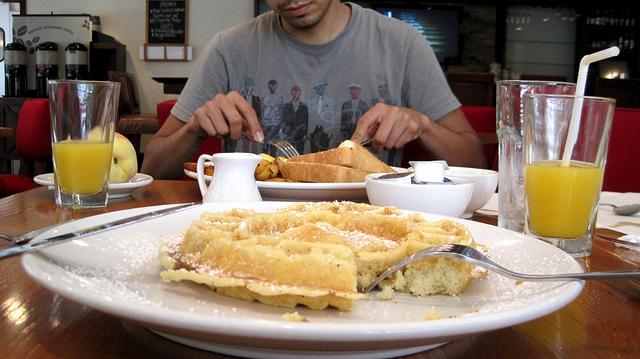What fruit does the juice come from?
Concise answer only. Orange. What is the food in the front of the picture called?
Be succinct. Waffle. What is the person doing?
Concise answer only. Eating. 